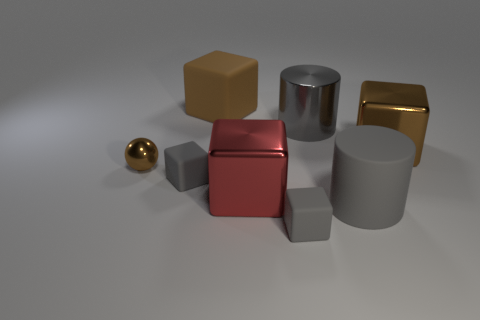This scene looks like it could be from an advertisement. What kind of product do you think it's promoting? The sleek shapes and polished surfaces suggest a modern and sophisticated aesthetic. This scene might promote a luxury home decor line or an artistic brand that focuses on contemporary design and minimalism. 